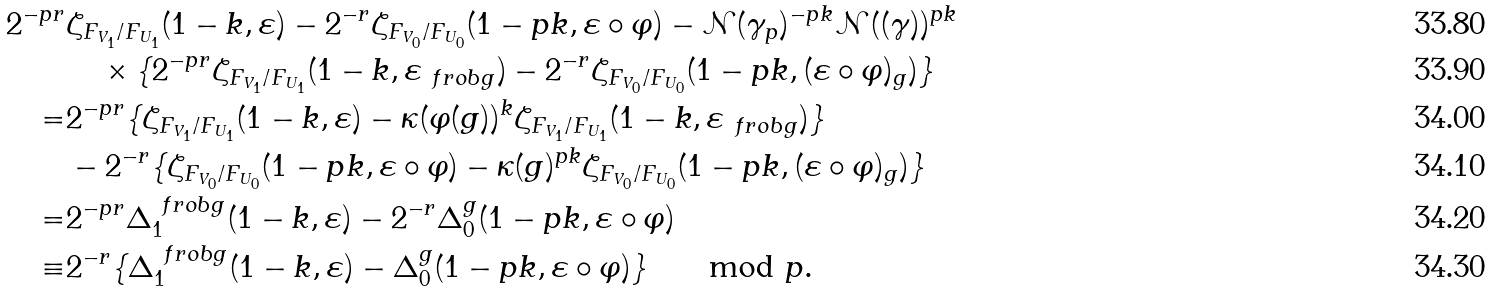<formula> <loc_0><loc_0><loc_500><loc_500>2 ^ { - p r } & \zeta _ { F _ { V _ { 1 } } / F _ { U _ { 1 } } } ( 1 - k , \varepsilon ) - 2 ^ { - r } \zeta _ { F _ { V _ { 0 } } / F _ { U _ { 0 } } } ( 1 - p k , \varepsilon \circ \varphi ) - \mathcal { N } ( \gamma _ { p } ) ^ { - p k } \mathcal { N } ( ( \gamma ) ) ^ { p k } \\ & \quad \times \{ 2 ^ { - p r } \zeta _ { F _ { V _ { 1 } } / F _ { U _ { 1 } } } ( 1 - k , \varepsilon _ { \ f r o b { g } } ) - 2 ^ { - r } \zeta _ { F _ { V _ { 0 } } / F _ { U _ { 0 } } } ( 1 - p k , ( \varepsilon \circ \varphi ) _ { g } ) \} \\ = & 2 ^ { - p r } \{ \zeta _ { F _ { V _ { 1 } } / F _ { U _ { 1 } } } ( 1 - k , \varepsilon ) - \kappa ( \varphi ( g ) ) ^ { k } \zeta _ { F _ { V _ { 1 } } / F _ { U _ { 1 } } } ( 1 - k , \varepsilon _ { \ f r o b { g } } ) \} \\ & - 2 ^ { - r } \{ \zeta _ { F _ { V _ { 0 } } / F _ { U _ { 0 } } } ( 1 - p k , \varepsilon \circ \varphi ) - \kappa ( g ) ^ { p k } \zeta _ { F _ { V _ { 0 } } / F _ { U _ { 0 } } } ( 1 - p k , ( \varepsilon \circ \varphi ) _ { g } ) \} \\ = & 2 ^ { - p r } \Delta _ { 1 } ^ { \ f r o b { g } } ( 1 - k , \varepsilon ) - 2 ^ { - r } \Delta _ { 0 } ^ { g } ( 1 - p k , \varepsilon \circ \varphi ) \\ \equiv & 2 ^ { - r } \{ \Delta _ { 1 } ^ { \ f r o b { g } } ( 1 - k , \varepsilon ) - \Delta _ { 0 } ^ { g } ( 1 - p k , \varepsilon \circ \varphi ) \} \quad \mod p .</formula> 